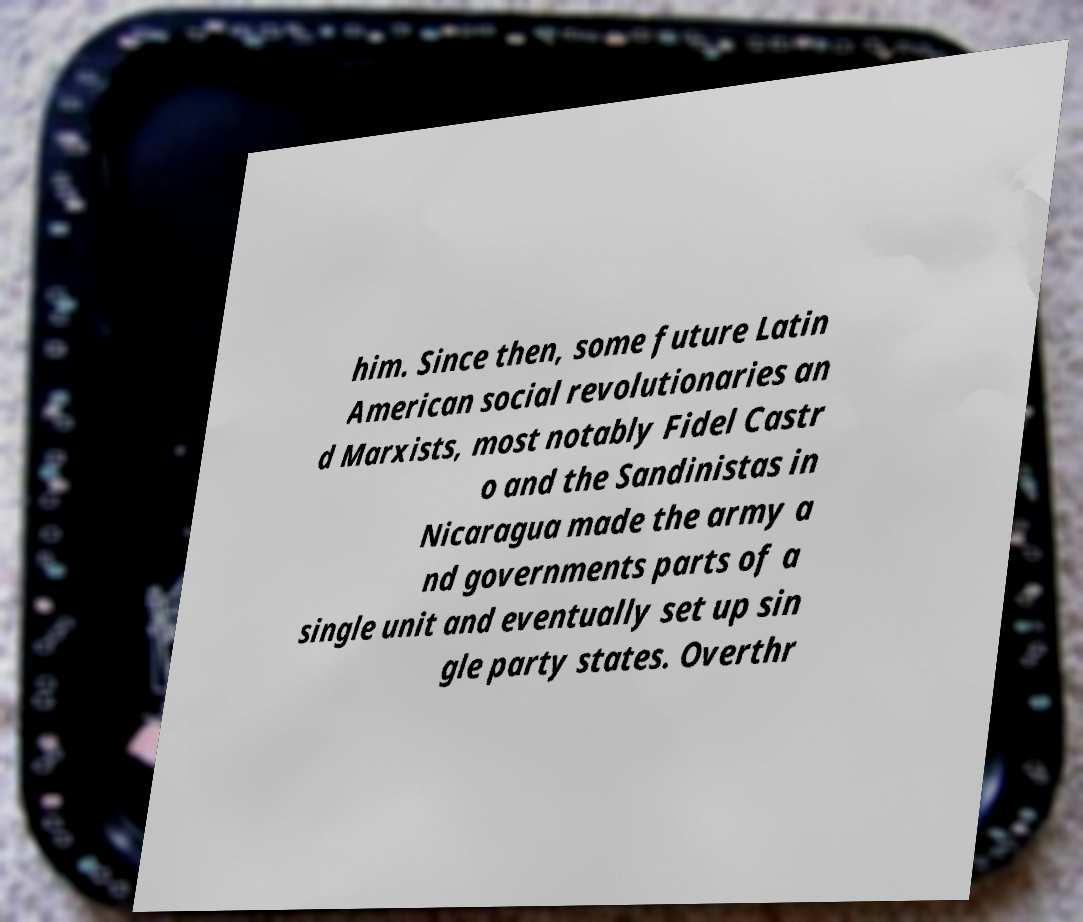Can you read and provide the text displayed in the image?This photo seems to have some interesting text. Can you extract and type it out for me? him. Since then, some future Latin American social revolutionaries an d Marxists, most notably Fidel Castr o and the Sandinistas in Nicaragua made the army a nd governments parts of a single unit and eventually set up sin gle party states. Overthr 